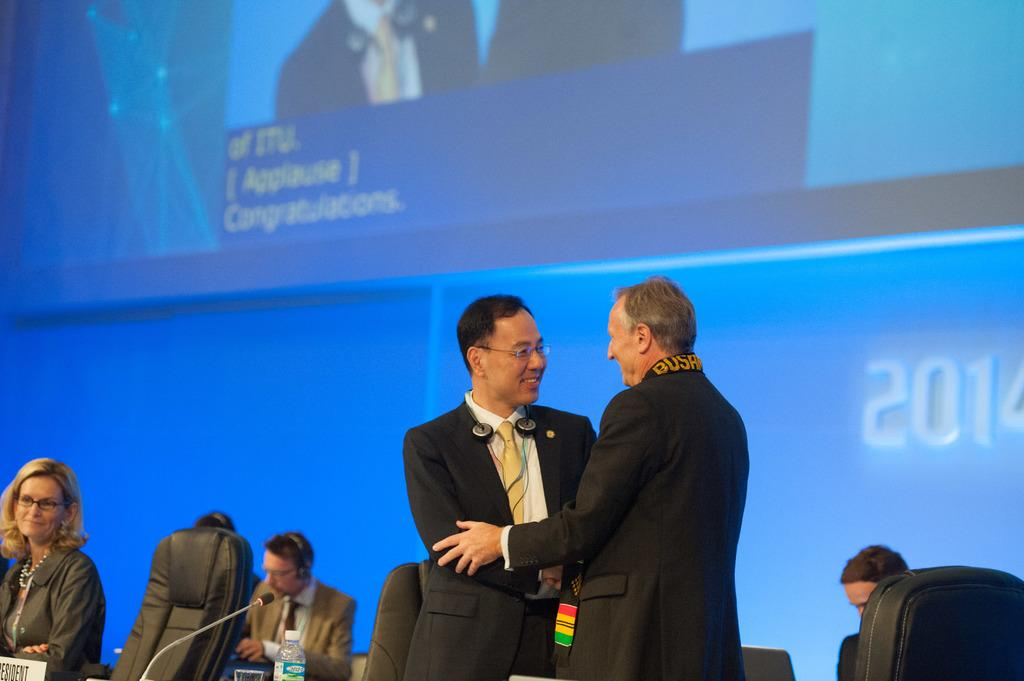How many men are in the image? There are two men standing in the center of the image. What objects are present at the bottom of the image? Chairs, a bottle, a board, and a mic are visible at the bottom of the image. What is located at the top of the image? There is a screen at the top of the image. What type of garden can be seen in the image? There is no garden present in the image. Is this image taken inside a home? The provided facts do not give any information about the location being a home or not. 